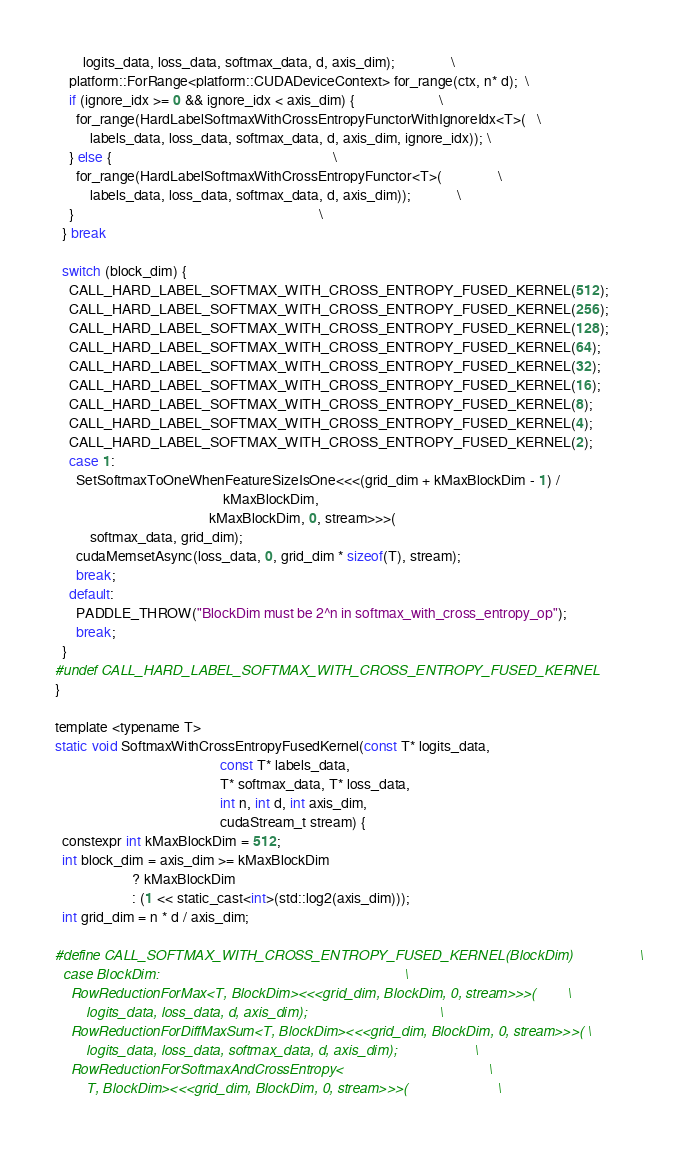Convert code to text. <code><loc_0><loc_0><loc_500><loc_500><_Cuda_>        logits_data, loss_data, softmax_data, d, axis_dim);                \
    platform::ForRange<platform::CUDADeviceContext> for_range(ctx, n* d);  \
    if (ignore_idx >= 0 && ignore_idx < axis_dim) {                        \
      for_range(HardLabelSoftmaxWithCrossEntropyFunctorWithIgnoreIdx<T>(   \
          labels_data, loss_data, softmax_data, d, axis_dim, ignore_idx)); \
    } else {                                                               \
      for_range(HardLabelSoftmaxWithCrossEntropyFunctor<T>(                \
          labels_data, loss_data, softmax_data, d, axis_dim));             \
    }                                                                      \
  } break

  switch (block_dim) {
    CALL_HARD_LABEL_SOFTMAX_WITH_CROSS_ENTROPY_FUSED_KERNEL(512);
    CALL_HARD_LABEL_SOFTMAX_WITH_CROSS_ENTROPY_FUSED_KERNEL(256);
    CALL_HARD_LABEL_SOFTMAX_WITH_CROSS_ENTROPY_FUSED_KERNEL(128);
    CALL_HARD_LABEL_SOFTMAX_WITH_CROSS_ENTROPY_FUSED_KERNEL(64);
    CALL_HARD_LABEL_SOFTMAX_WITH_CROSS_ENTROPY_FUSED_KERNEL(32);
    CALL_HARD_LABEL_SOFTMAX_WITH_CROSS_ENTROPY_FUSED_KERNEL(16);
    CALL_HARD_LABEL_SOFTMAX_WITH_CROSS_ENTROPY_FUSED_KERNEL(8);
    CALL_HARD_LABEL_SOFTMAX_WITH_CROSS_ENTROPY_FUSED_KERNEL(4);
    CALL_HARD_LABEL_SOFTMAX_WITH_CROSS_ENTROPY_FUSED_KERNEL(2);
    case 1:
      SetSoftmaxToOneWhenFeatureSizeIsOne<<<(grid_dim + kMaxBlockDim - 1) /
                                                kMaxBlockDim,
                                            kMaxBlockDim, 0, stream>>>(
          softmax_data, grid_dim);
      cudaMemsetAsync(loss_data, 0, grid_dim * sizeof(T), stream);
      break;
    default:
      PADDLE_THROW("BlockDim must be 2^n in softmax_with_cross_entropy_op");
      break;
  }
#undef CALL_HARD_LABEL_SOFTMAX_WITH_CROSS_ENTROPY_FUSED_KERNEL
}

template <typename T>
static void SoftmaxWithCrossEntropyFusedKernel(const T* logits_data,
                                               const T* labels_data,
                                               T* softmax_data, T* loss_data,
                                               int n, int d, int axis_dim,
                                               cudaStream_t stream) {
  constexpr int kMaxBlockDim = 512;
  int block_dim = axis_dim >= kMaxBlockDim
                      ? kMaxBlockDim
                      : (1 << static_cast<int>(std::log2(axis_dim)));
  int grid_dim = n * d / axis_dim;

#define CALL_SOFTMAX_WITH_CROSS_ENTROPY_FUSED_KERNEL(BlockDim)                 \
  case BlockDim:                                                               \
    RowReductionForMax<T, BlockDim><<<grid_dim, BlockDim, 0, stream>>>(        \
        logits_data, loss_data, d, axis_dim);                                  \
    RowReductionForDiffMaxSum<T, BlockDim><<<grid_dim, BlockDim, 0, stream>>>( \
        logits_data, loss_data, softmax_data, d, axis_dim);                    \
    RowReductionForSoftmaxAndCrossEntropy<                                     \
        T, BlockDim><<<grid_dim, BlockDim, 0, stream>>>(                       \</code> 